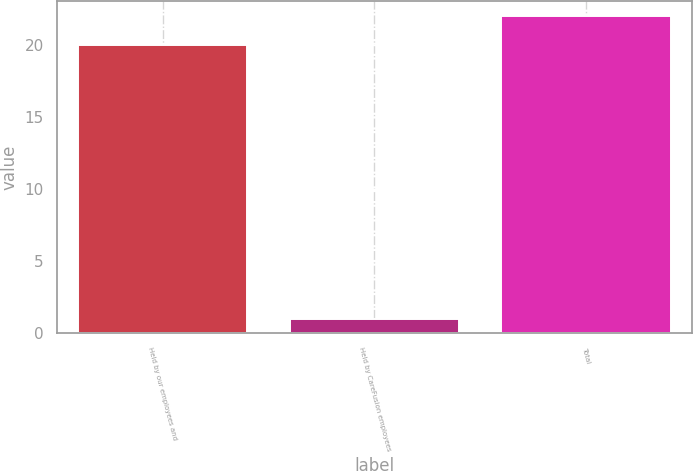<chart> <loc_0><loc_0><loc_500><loc_500><bar_chart><fcel>Held by our employees and<fcel>Held by CareFusion employees<fcel>Total<nl><fcel>20<fcel>1<fcel>22<nl></chart> 